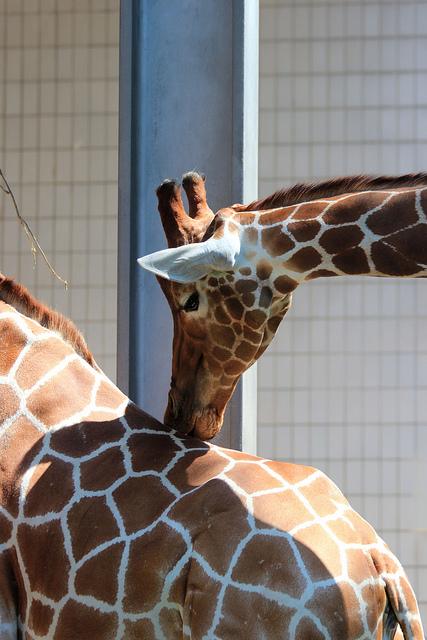Can the giraffe smell the other giraffe's back?
Be succinct. Yes. Are they on the African plains?
Quick response, please. No. How many giraffes are there?
Write a very short answer. 2. 